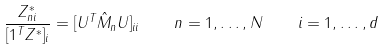<formula> <loc_0><loc_0><loc_500><loc_500>\frac { Z ^ { * } _ { n i } } { [ 1 ^ { T } Z ^ { * } ] _ { i } } = [ U ^ { T } \hat { M } _ { n } U ] _ { i i } \quad n = 1 , \dots , N \quad i = 1 , \dots , d</formula> 